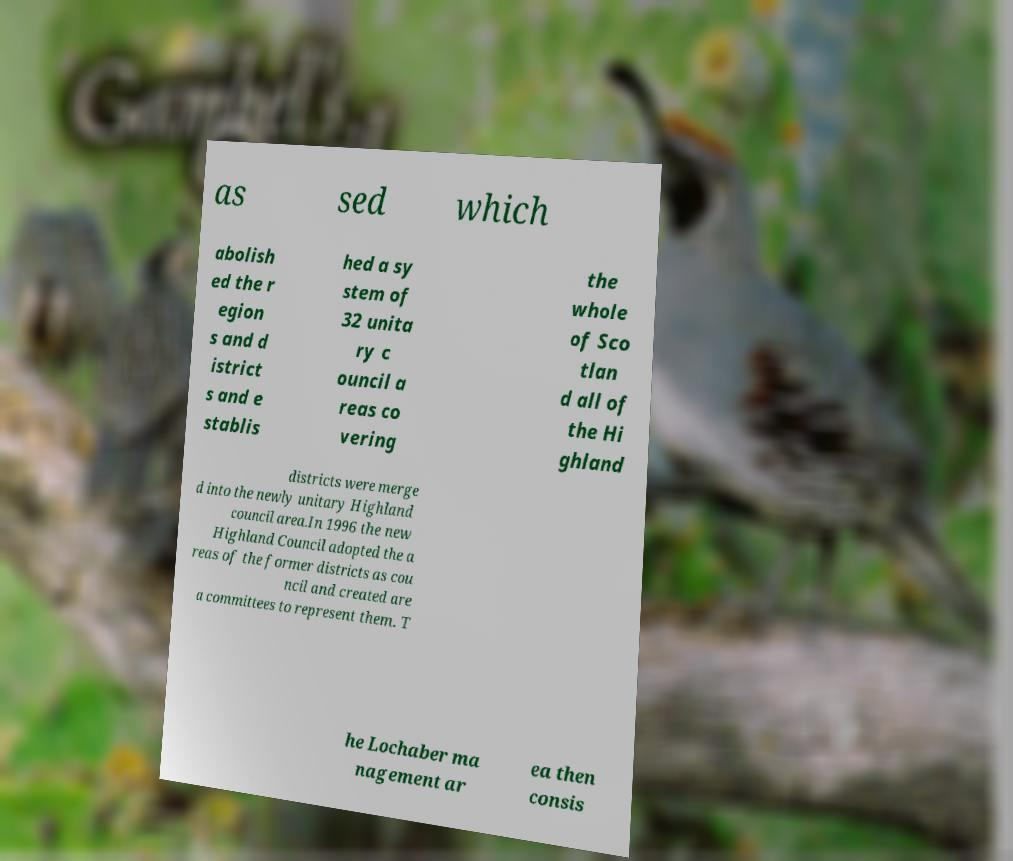Can you accurately transcribe the text from the provided image for me? as sed which abolish ed the r egion s and d istrict s and e stablis hed a sy stem of 32 unita ry c ouncil a reas co vering the whole of Sco tlan d all of the Hi ghland districts were merge d into the newly unitary Highland council area.In 1996 the new Highland Council adopted the a reas of the former districts as cou ncil and created are a committees to represent them. T he Lochaber ma nagement ar ea then consis 